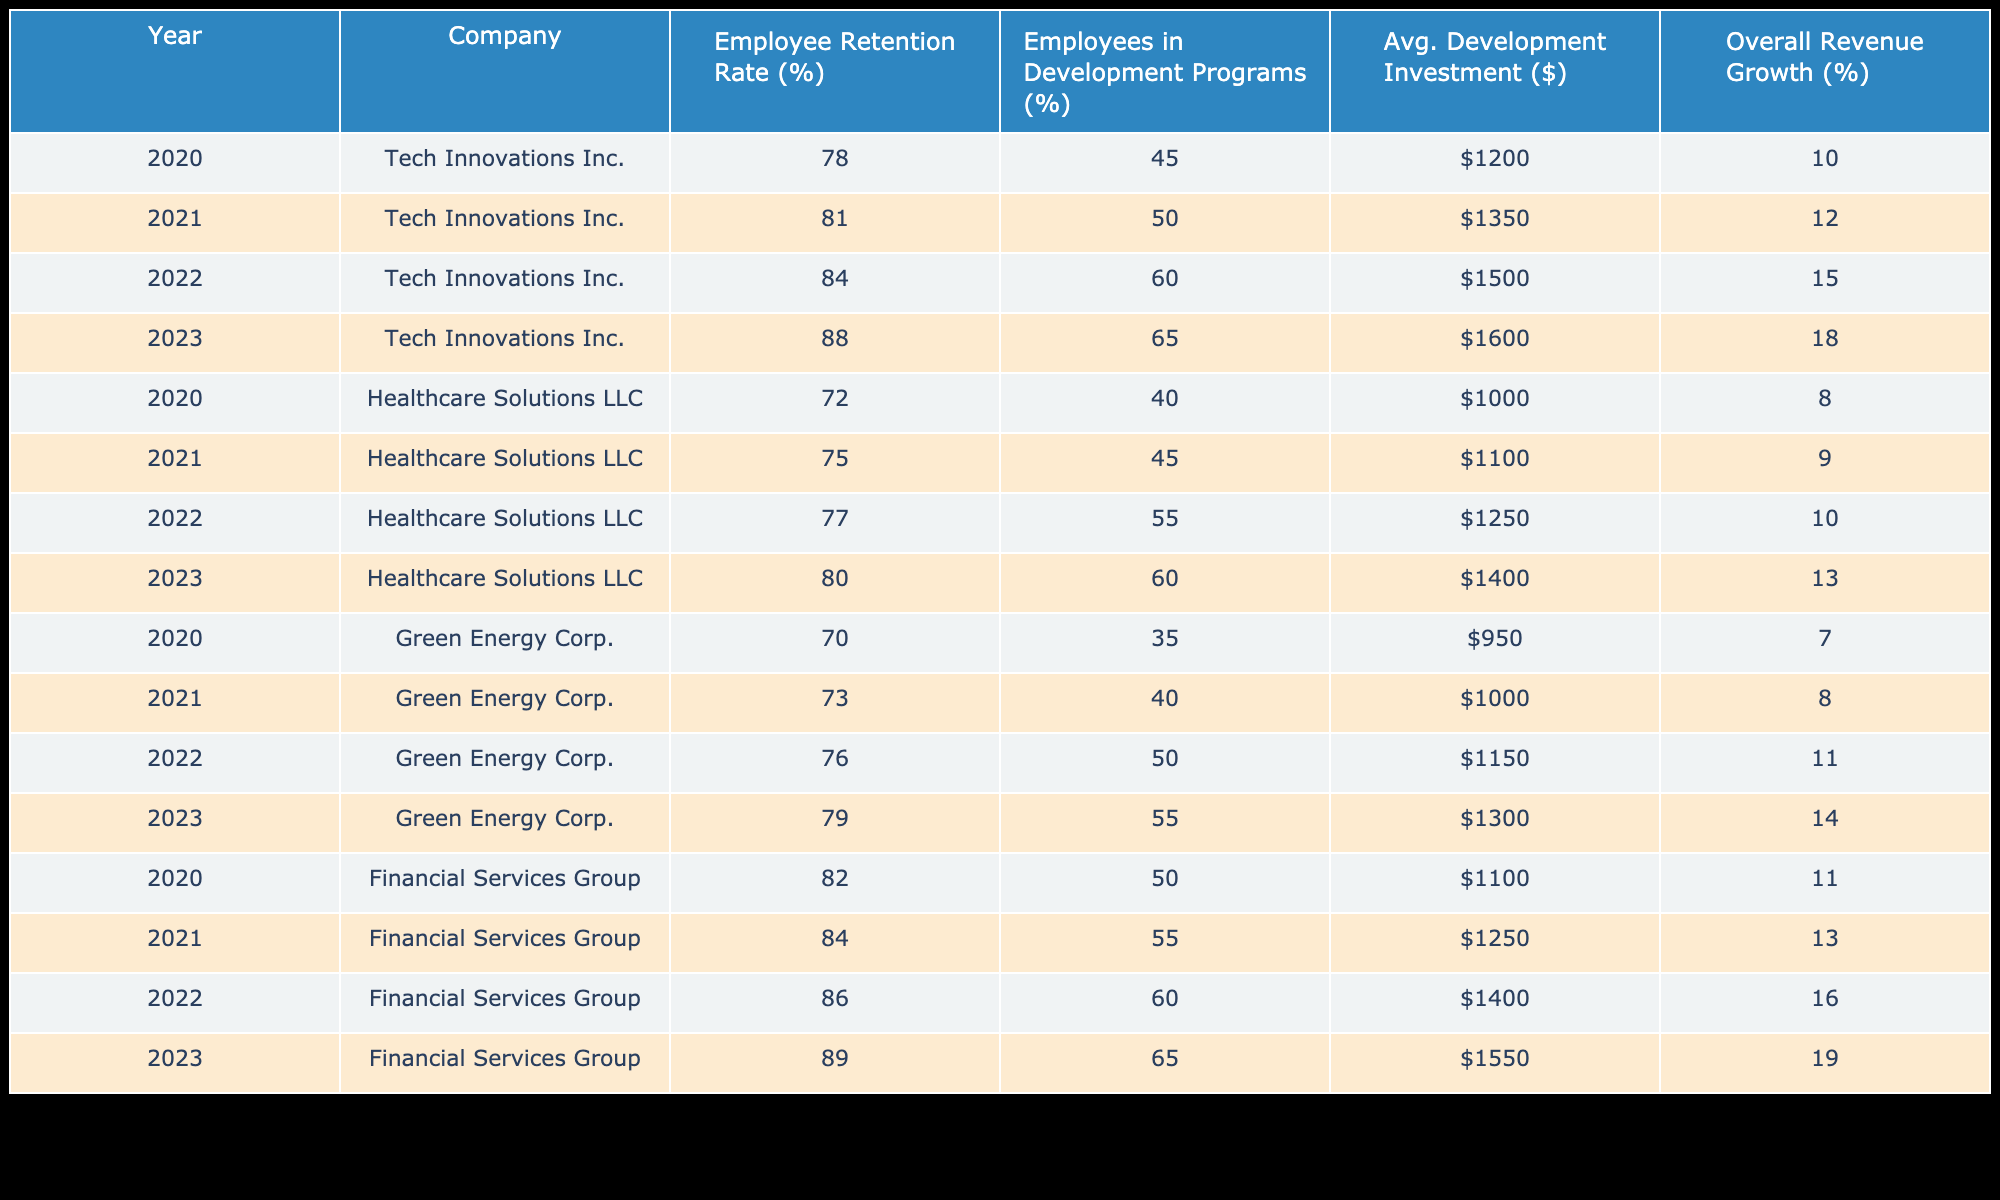What was the employee retention rate for Tech Innovations Inc. in 2022? The table shows that the employee retention rate for Tech Innovations Inc. in 2022 was 84%.
Answer: 84% Which company had the lowest employee retention rate in 2020? In 2020, Green Energy Corp. reported a retention rate of 70%, which is the lowest compared to other companies in the same year.
Answer: Green Energy Corp What is the average development investment per employee for Healthcare Solutions LLC from 2020 to 2023? To calculate the average, add the investment values for each year: 1000 + 1100 + 1250 + 1400 = 4750. Then, divide by the number of years (4): 4750 / 4 = 1187.5.
Answer: 1187.5 Did the employee retention rate consistently increase for Financial Services Group from 2020 to 2023? Checking the values, we see that the retention rates for Financial Services Group were 82%, 84%, 86%, and 89%, respectively, indicating a consistent increase over the four years.
Answer: Yes What was the percentage increase in employee retention rate for Green Energy Corp. from 2020 to 2023? For Green Energy Corp., the retention rates were 70% in 2020 and 79% in 2023. The increase is calculated as (79 - 70) / 70 * 100, which simplifies to 12.86%.
Answer: 12.86% 